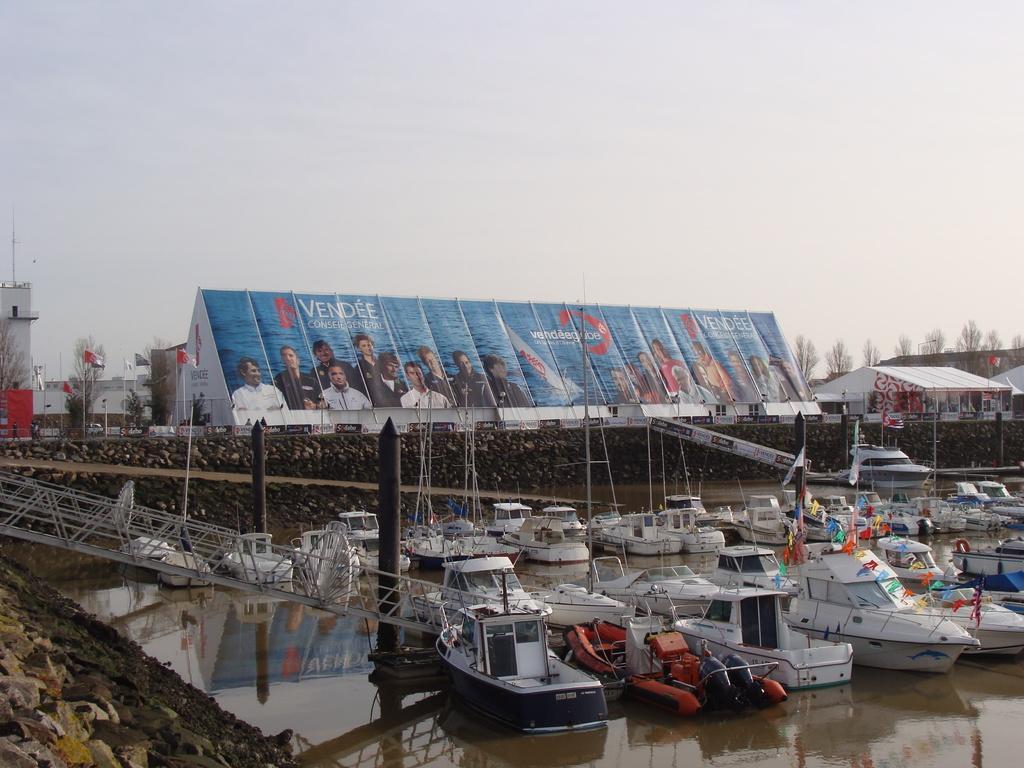Please provide a concise description of this image. Here in this picture we can see number of boats present in the water and on the right side we can see sheds present and in the middle we can see banners present on the shed and we can also see plants and trees present in the far and we can also see buildings and we can see the sky is cloudy. 